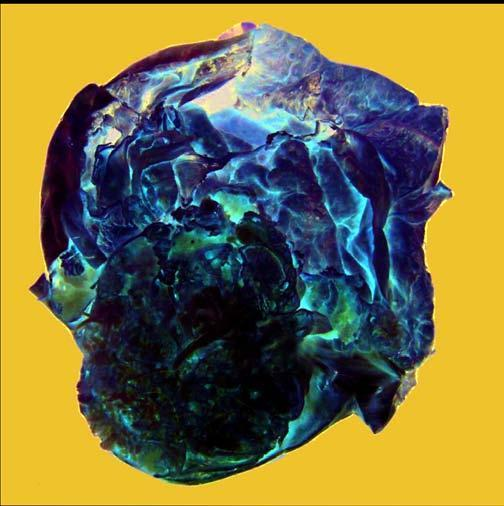what shows presence of loculi containing gelatinous mucoid material?
Answer the question using a single word or phrase. Cyst wall 